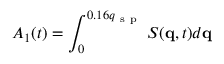<formula> <loc_0><loc_0><loc_500><loc_500>A _ { 1 } ( t ) = \int _ { 0 } ^ { 0 . 1 6 q _ { s p } } { S ( q , t ) d q }</formula> 